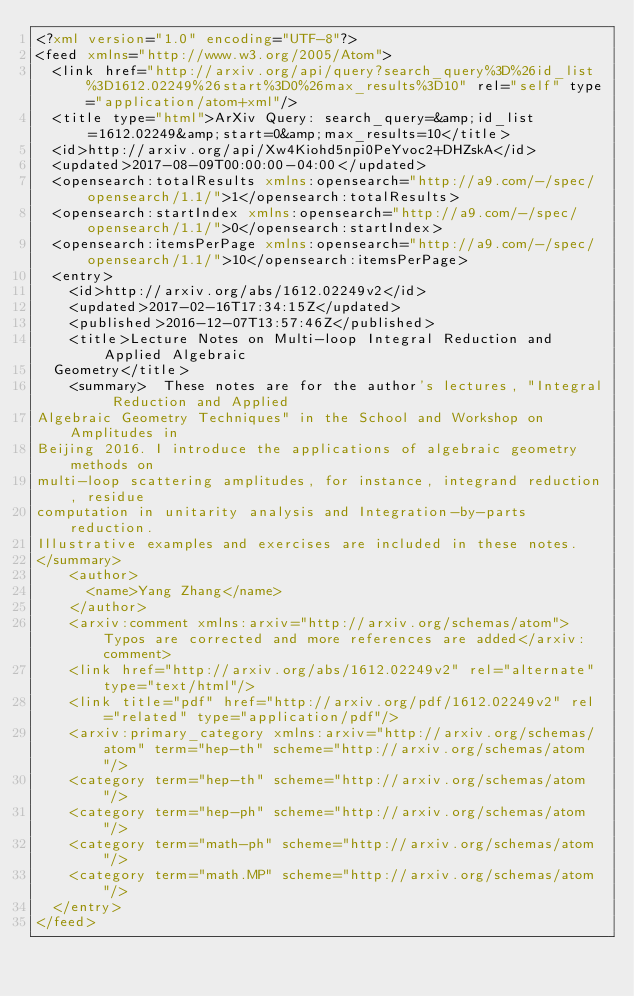<code> <loc_0><loc_0><loc_500><loc_500><_XML_><?xml version="1.0" encoding="UTF-8"?>
<feed xmlns="http://www.w3.org/2005/Atom">
  <link href="http://arxiv.org/api/query?search_query%3D%26id_list%3D1612.02249%26start%3D0%26max_results%3D10" rel="self" type="application/atom+xml"/>
  <title type="html">ArXiv Query: search_query=&amp;id_list=1612.02249&amp;start=0&amp;max_results=10</title>
  <id>http://arxiv.org/api/Xw4Kiohd5npi0PeYvoc2+DHZskA</id>
  <updated>2017-08-09T00:00:00-04:00</updated>
  <opensearch:totalResults xmlns:opensearch="http://a9.com/-/spec/opensearch/1.1/">1</opensearch:totalResults>
  <opensearch:startIndex xmlns:opensearch="http://a9.com/-/spec/opensearch/1.1/">0</opensearch:startIndex>
  <opensearch:itemsPerPage xmlns:opensearch="http://a9.com/-/spec/opensearch/1.1/">10</opensearch:itemsPerPage>
  <entry>
    <id>http://arxiv.org/abs/1612.02249v2</id>
    <updated>2017-02-16T17:34:15Z</updated>
    <published>2016-12-07T13:57:46Z</published>
    <title>Lecture Notes on Multi-loop Integral Reduction and Applied Algebraic
  Geometry</title>
    <summary>  These notes are for the author's lectures, "Integral Reduction and Applied
Algebraic Geometry Techniques" in the School and Workshop on Amplitudes in
Beijing 2016. I introduce the applications of algebraic geometry methods on
multi-loop scattering amplitudes, for instance, integrand reduction, residue
computation in unitarity analysis and Integration-by-parts reduction.
Illustrative examples and exercises are included in these notes.
</summary>
    <author>
      <name>Yang Zhang</name>
    </author>
    <arxiv:comment xmlns:arxiv="http://arxiv.org/schemas/atom">Typos are corrected and more references are added</arxiv:comment>
    <link href="http://arxiv.org/abs/1612.02249v2" rel="alternate" type="text/html"/>
    <link title="pdf" href="http://arxiv.org/pdf/1612.02249v2" rel="related" type="application/pdf"/>
    <arxiv:primary_category xmlns:arxiv="http://arxiv.org/schemas/atom" term="hep-th" scheme="http://arxiv.org/schemas/atom"/>
    <category term="hep-th" scheme="http://arxiv.org/schemas/atom"/>
    <category term="hep-ph" scheme="http://arxiv.org/schemas/atom"/>
    <category term="math-ph" scheme="http://arxiv.org/schemas/atom"/>
    <category term="math.MP" scheme="http://arxiv.org/schemas/atom"/>
  </entry>
</feed>
</code> 